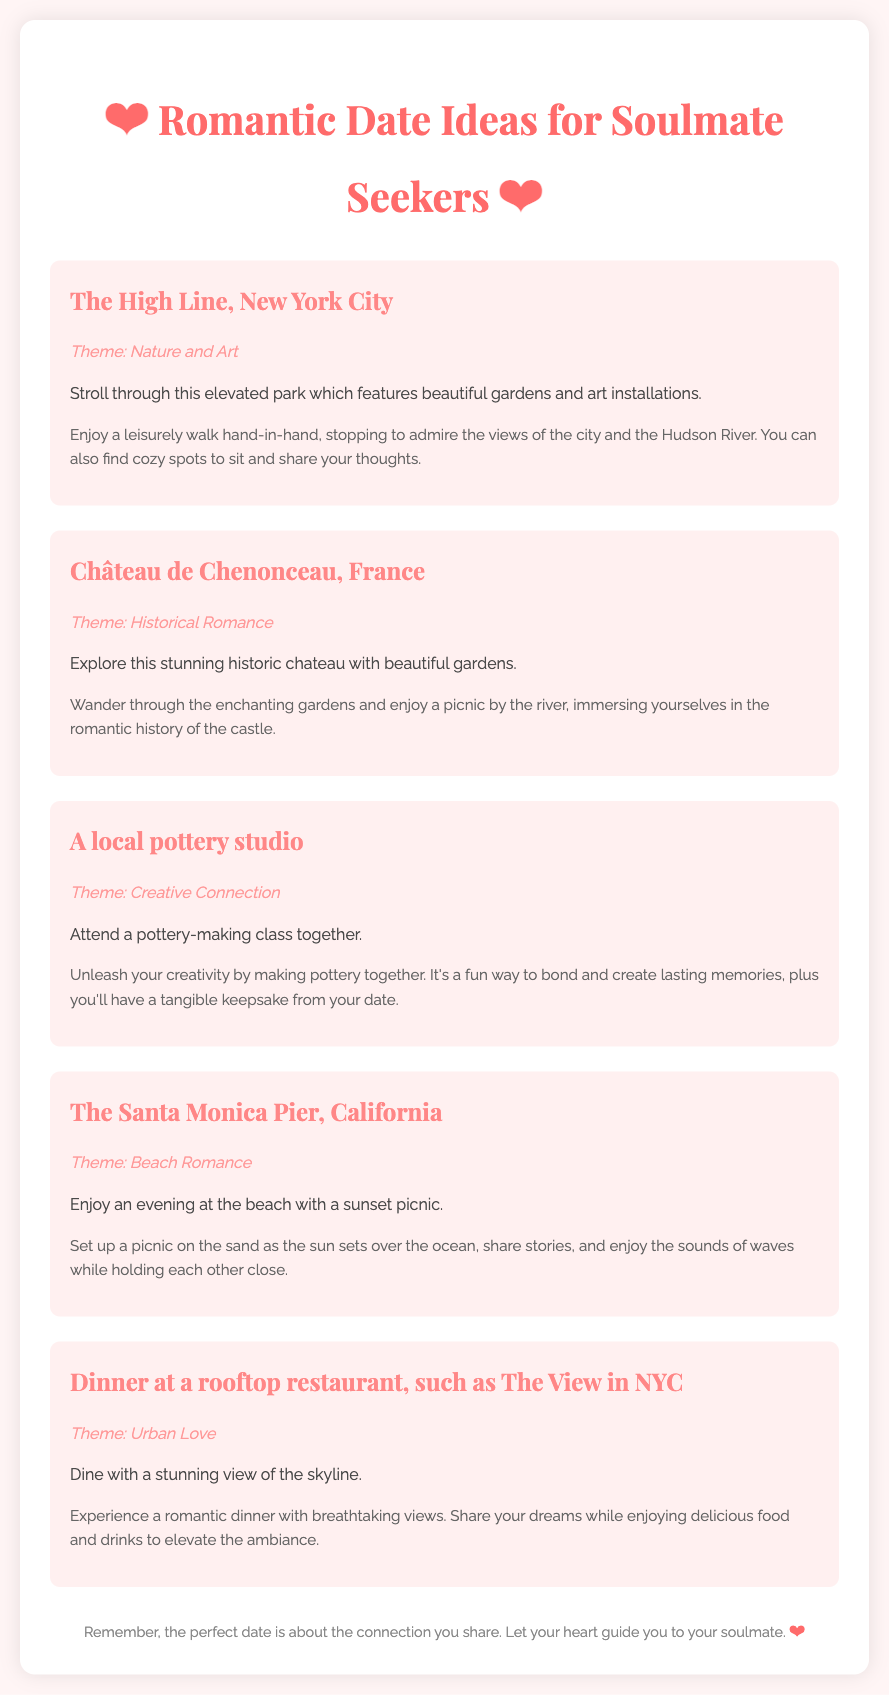what is the first date idea mentioned? The first date idea is identified by the title of the section, mentioning "The High Line, New York City."
Answer: The High Line, New York City what theme is associated with the Santa Monica Pier date idea? The theme can be found in the description of the date idea, specifically labelled under the theme section.
Answer: Beach Romance how many date ideas are listed in the document? The total number of date ideas can be counted from the number of sections labeled as "date-idea" in the document.
Answer: Five what type of venue is suggested for a creative connection date? The specific venue is directly mentioned in the date idea description focusing on creativity and connection.
Answer: Local pottery studio what activity is suggested to be done at Château de Chenonceau? The activity is explicitly described in the portion that outlines what to do at the chateau.
Answer: Picnic by the river what is the suggested setting for the rooftop restaurant dinner? This setting is summarized in the theme and description related to the dining experience.
Answer: Skyline view 